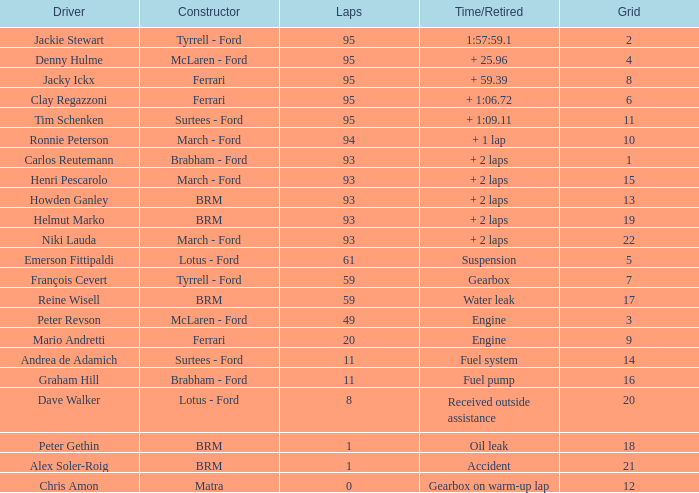Which grid has less than 11 laps, and a Time/Retired of accident? 21.0. 